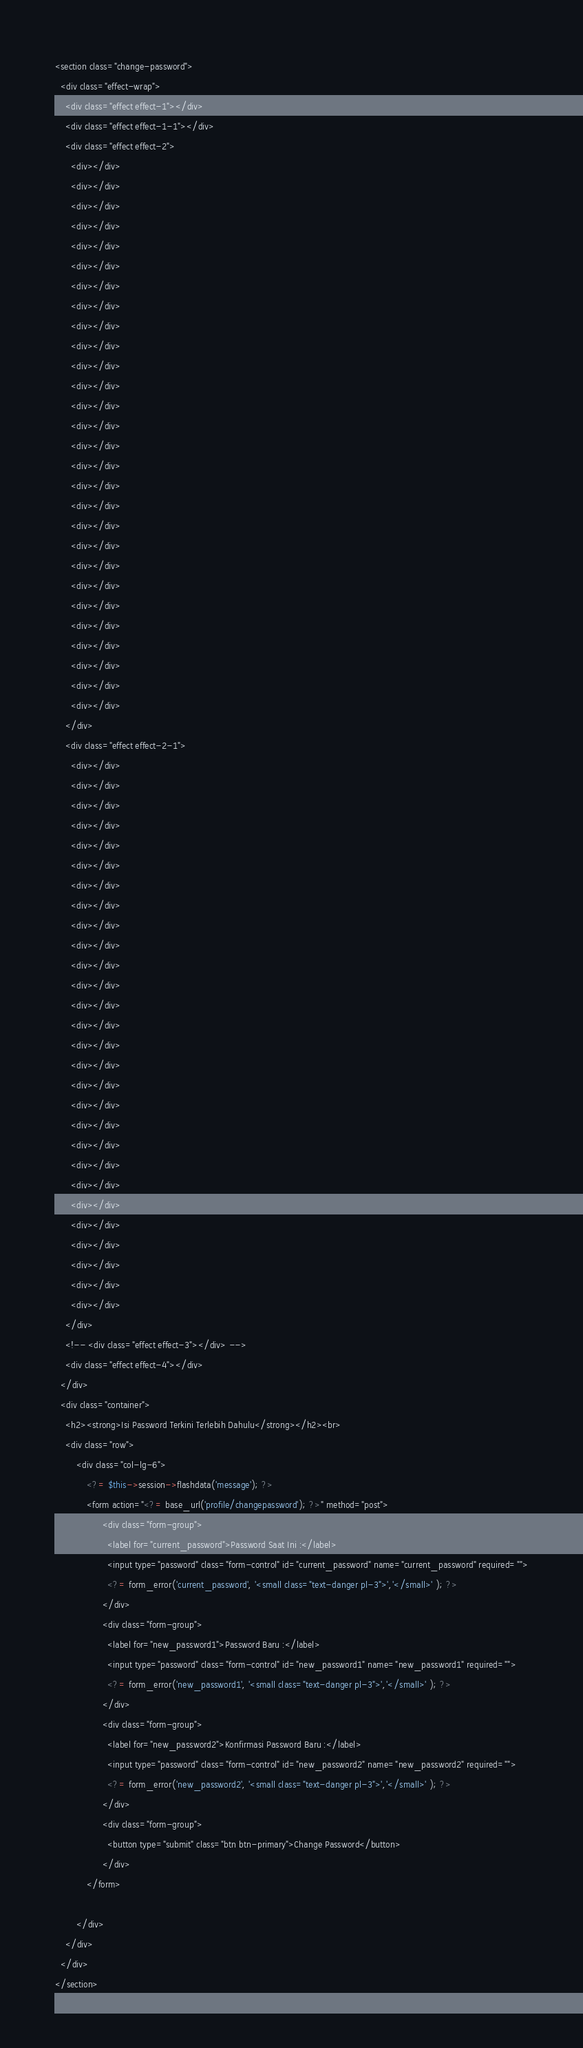Convert code to text. <code><loc_0><loc_0><loc_500><loc_500><_PHP_><section class="change-password">
  <div class="effect-wrap">
    <div class="effect effect-1"></div>
    <div class="effect effect-1-1"></div>
    <div class="effect effect-2">
      <div></div>
      <div></div>
      <div></div>
      <div></div>
      <div></div>
      <div></div>
      <div></div>
      <div></div>
      <div></div>
      <div></div>
      <div></div>
      <div></div>
      <div></div>
      <div></div>
      <div></div>
      <div></div>
      <div></div>
      <div></div>
      <div></div>
      <div></div>
      <div></div>
      <div></div>
      <div></div>
      <div></div>
      <div></div>
      <div></div>
      <div></div>
      <div></div>
    </div>
    <div class="effect effect-2-1">
      <div></div>
      <div></div>
      <div></div>
      <div></div>
      <div></div>
      <div></div>
      <div></div>
      <div></div>
      <div></div>
      <div></div>
      <div></div>
      <div></div>
      <div></div>
      <div></div>
      <div></div>
      <div></div>
      <div></div>
      <div></div>
      <div></div>
      <div></div>
      <div></div>
      <div></div>
      <div></div>
      <div></div>
      <div></div>
      <div></div>
      <div></div>
      <div></div>
    </div>
    <!-- <div class="effect effect-3"></div> -->
    <div class="effect effect-4"></div>
  </div>
  <div class="container">
    <h2><strong>Isi Password Terkini Terlebih Dahulu</strong></h2><br>
    <div class="row">
        <div class="col-lg-6">
            <?= $this->session->flashdata('message'); ?>
            <form action="<?= base_url('profile/changepassword'); ?>" method="post">
                  <div class="form-group">
                    <label for="current_password">Password Saat Ini :</label>
                    <input type="password" class="form-control" id="current_password" name="current_password" required="">
                    <?= form_error('current_password', '<small class="text-danger pl-3">','</small>' ); ?>
                  </div>
                  <div class="form-group">
                    <label for="new_password1">Password Baru :</label>
                    <input type="password" class="form-control" id="new_password1" name="new_password1" required="">
                    <?= form_error('new_password1', '<small class="text-danger pl-3">','</small>' ); ?>
                  </div>
                  <div class="form-group">
                    <label for="new_password2">Konfirmasi Password Baru :</label>
                    <input type="password" class="form-control" id="new_password2" name="new_password2" required="">
                    <?= form_error('new_password2', '<small class="text-danger pl-3">','</small>' ); ?>
                  </div>
                  <div class="form-group">
                    <button type="submit" class="btn btn-primary">Change Password</button>
                  </div>
            </form>
            
        </div>
    </div>
  </div>
</section></code> 